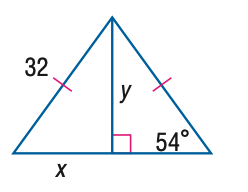Question: Find y. Round to the nearest tenth.
Choices:
A. 18.8
B. 23.2
C. 25.9
D. 44.0
Answer with the letter. Answer: C 